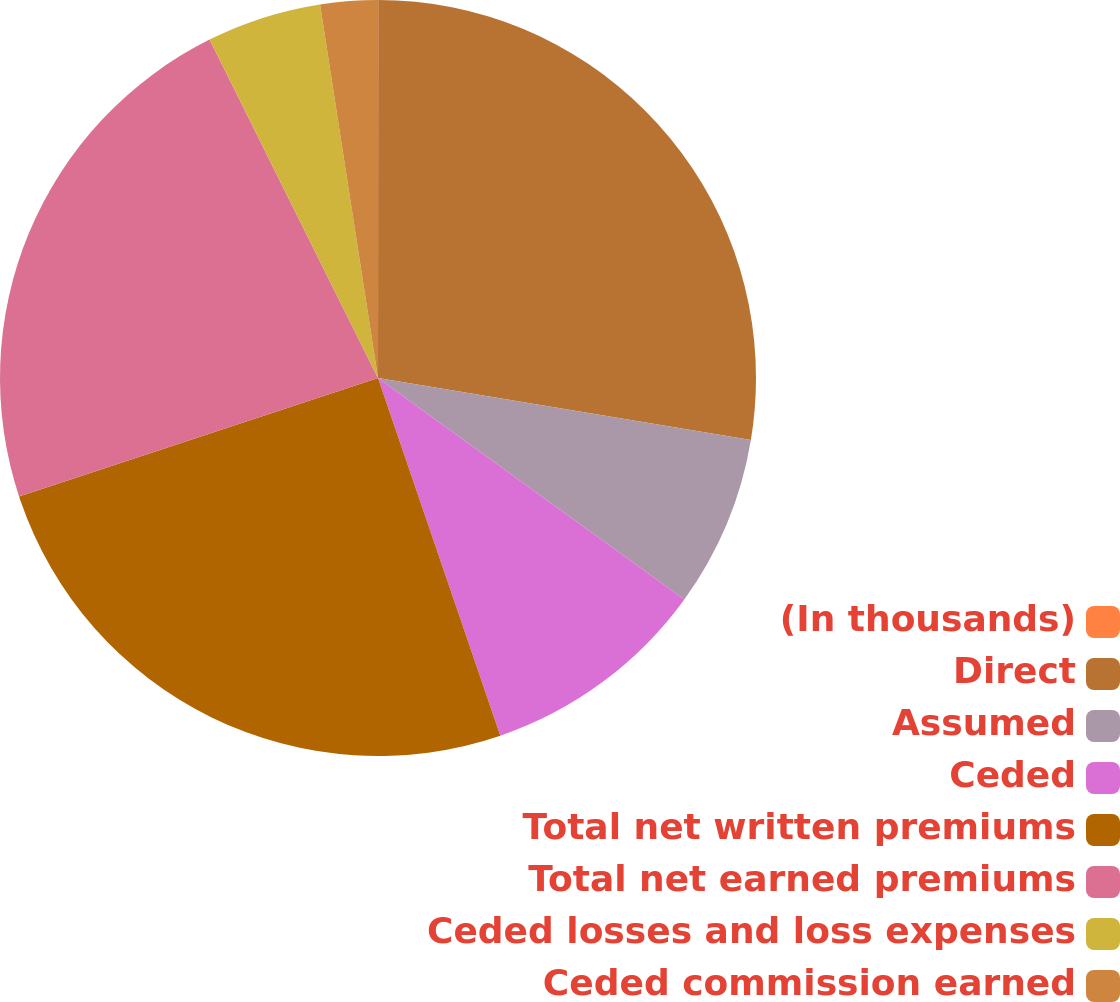Convert chart. <chart><loc_0><loc_0><loc_500><loc_500><pie_chart><fcel>(In thousands)<fcel>Direct<fcel>Assumed<fcel>Ceded<fcel>Total net written premiums<fcel>Total net earned premiums<fcel>Ceded losses and loss expenses<fcel>Ceded commission earned<nl><fcel>0.01%<fcel>27.61%<fcel>7.34%<fcel>9.79%<fcel>25.17%<fcel>22.72%<fcel>4.9%<fcel>2.45%<nl></chart> 